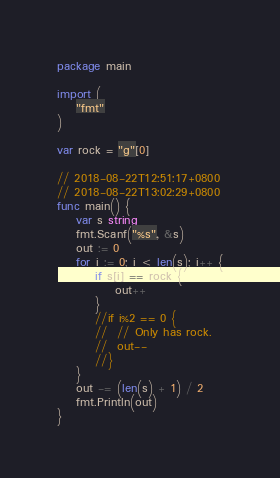<code> <loc_0><loc_0><loc_500><loc_500><_Go_>package main

import (
	"fmt"
)

var rock = "g"[0]

// 2018-08-22T12:51:17+0800
// 2018-08-22T13:02:29+0800
func main() {
	var s string
	fmt.Scanf("%s", &s)
	out := 0
	for i := 0; i < len(s); i++ {
		if s[i] == rock {
			out++
		}
		//if i%2 == 0 {
		//	// Only has rock.
		//	out--
		//}
	}
	out -= (len(s) + 1) / 2
	fmt.Println(out)
}</code> 